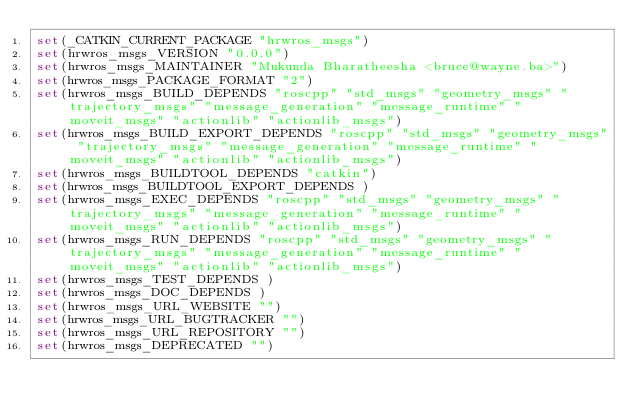Convert code to text. <code><loc_0><loc_0><loc_500><loc_500><_CMake_>set(_CATKIN_CURRENT_PACKAGE "hrwros_msgs")
set(hrwros_msgs_VERSION "0.0.0")
set(hrwros_msgs_MAINTAINER "Mukunda Bharatheesha <bruce@wayne.ba>")
set(hrwros_msgs_PACKAGE_FORMAT "2")
set(hrwros_msgs_BUILD_DEPENDS "roscpp" "std_msgs" "geometry_msgs" "trajectory_msgs" "message_generation" "message_runtime" "moveit_msgs" "actionlib" "actionlib_msgs")
set(hrwros_msgs_BUILD_EXPORT_DEPENDS "roscpp" "std_msgs" "geometry_msgs" "trajectory_msgs" "message_generation" "message_runtime" "moveit_msgs" "actionlib" "actionlib_msgs")
set(hrwros_msgs_BUILDTOOL_DEPENDS "catkin")
set(hrwros_msgs_BUILDTOOL_EXPORT_DEPENDS )
set(hrwros_msgs_EXEC_DEPENDS "roscpp" "std_msgs" "geometry_msgs" "trajectory_msgs" "message_generation" "message_runtime" "moveit_msgs" "actionlib" "actionlib_msgs")
set(hrwros_msgs_RUN_DEPENDS "roscpp" "std_msgs" "geometry_msgs" "trajectory_msgs" "message_generation" "message_runtime" "moveit_msgs" "actionlib" "actionlib_msgs")
set(hrwros_msgs_TEST_DEPENDS )
set(hrwros_msgs_DOC_DEPENDS )
set(hrwros_msgs_URL_WEBSITE "")
set(hrwros_msgs_URL_BUGTRACKER "")
set(hrwros_msgs_URL_REPOSITORY "")
set(hrwros_msgs_DEPRECATED "")</code> 